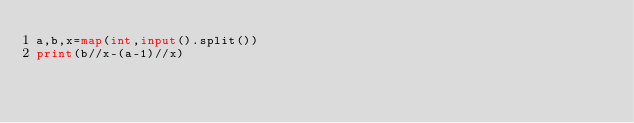Convert code to text. <code><loc_0><loc_0><loc_500><loc_500><_Python_>a,b,x=map(int,input().split())
print(b//x-(a-1)//x)</code> 